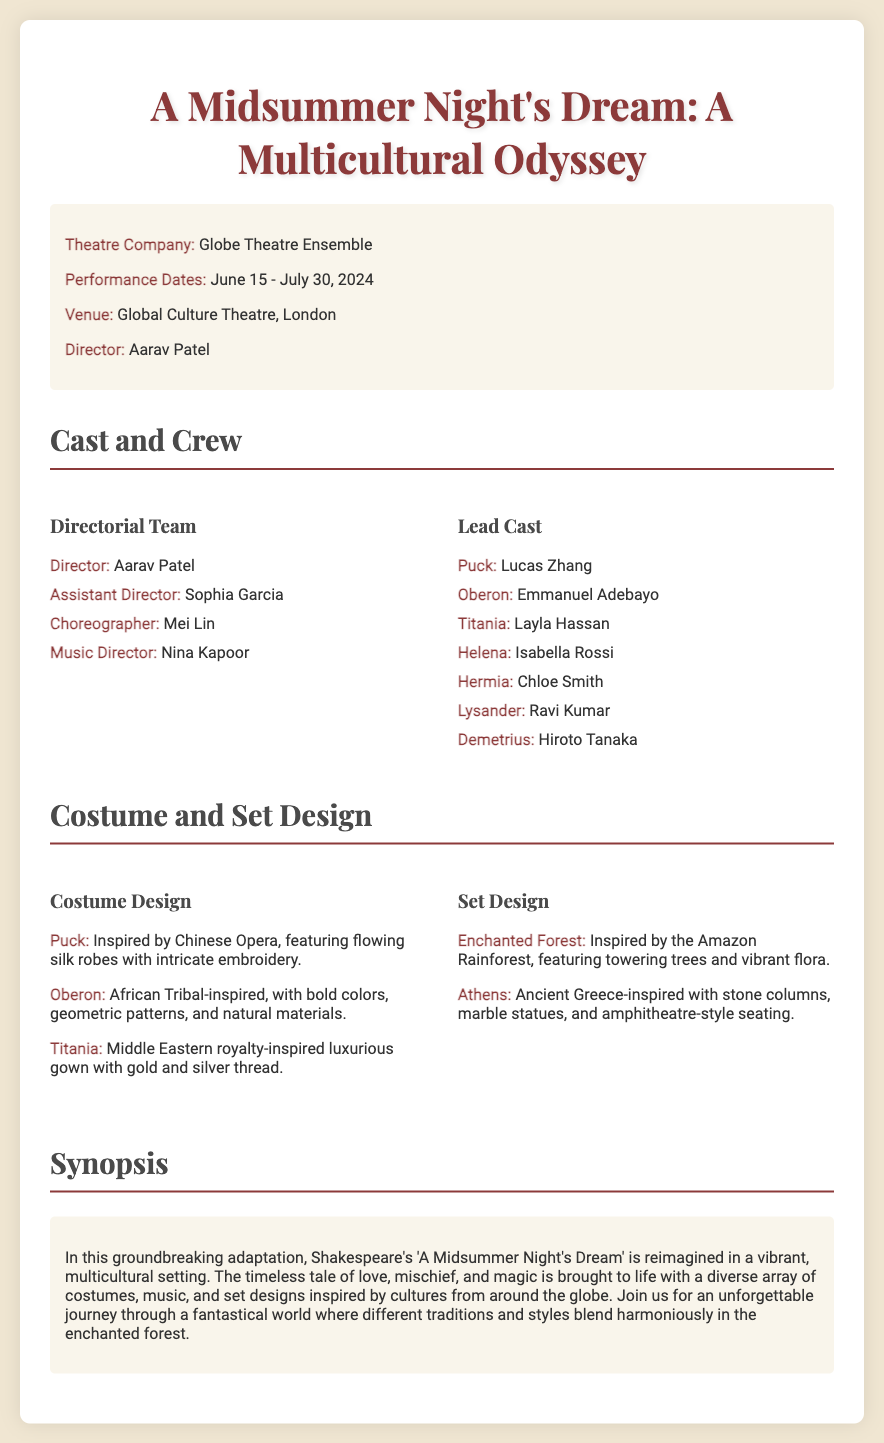what is the title of the play? The title is prominently displayed at the top of the document.
Answer: A Midsummer Night's Dream: A Multicultural Odyssey who is the director of the play? The director's name is mentioned under the production details section.
Answer: Aarav Patel when is the performance scheduled to begin? The performance date is specified in the production details section.
Answer: June 15, 2024 what is the primary inspiration for Puck's costume? The costume design section describes the inspiration for Puck's costume.
Answer: Chinese Opera what type of set design is used for the Enchanted Forest? The set design section provides insight into the design inspiration for the Enchanted Forest.
Answer: Amazon Rainforest how many lead cast members are listed? By counting the number of names listed under the lead cast section, we can determine the total.
Answer: 7 what cultural influences are reflected in Titania's costume? The costume design section describes the specific cultural inspiration for Titania's costume.
Answer: Middle Eastern royalty which venue will host the performance? The venue is clearly stated in the production details of the document.
Answer: Global Culture Theatre, London who is responsible for the music direction? The music director's name is listed among the directorial team in the cast and crew section.
Answer: Nina Kapoor 